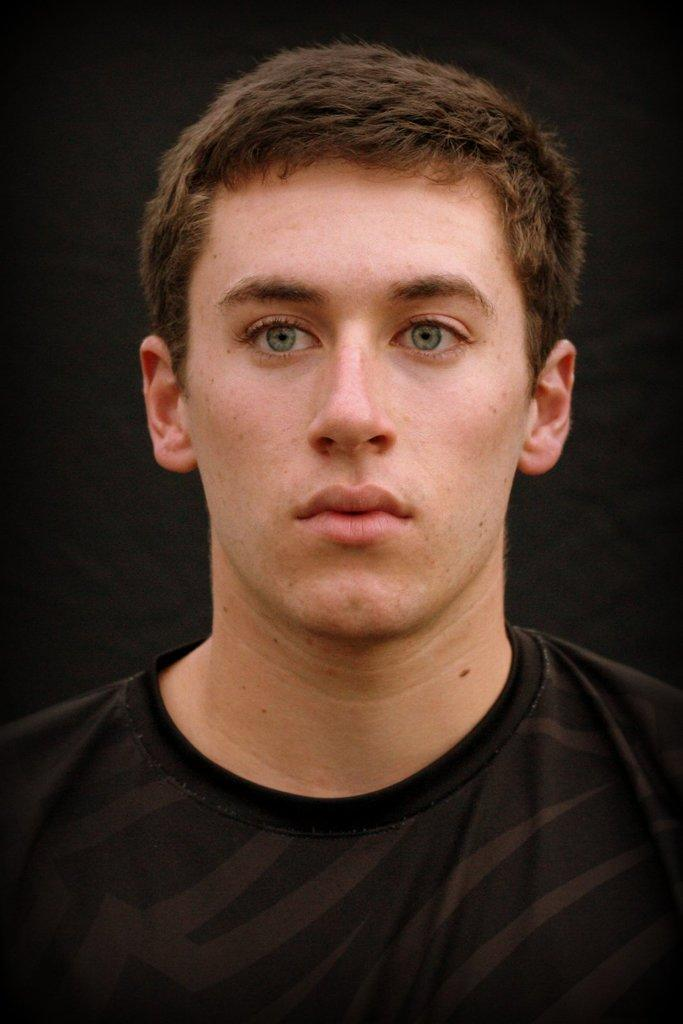Who is present in the image? There is a man in the image. What is the man wearing? The man is wearing a black T-shirt. What can be seen behind the man in the image? The background of the image is black in color. How many passengers are waiting at the pump in the image? There is no pump or passengers present in the image. What type of school is visible in the background of the image? There is no school visible in the image; the background is black in color. 